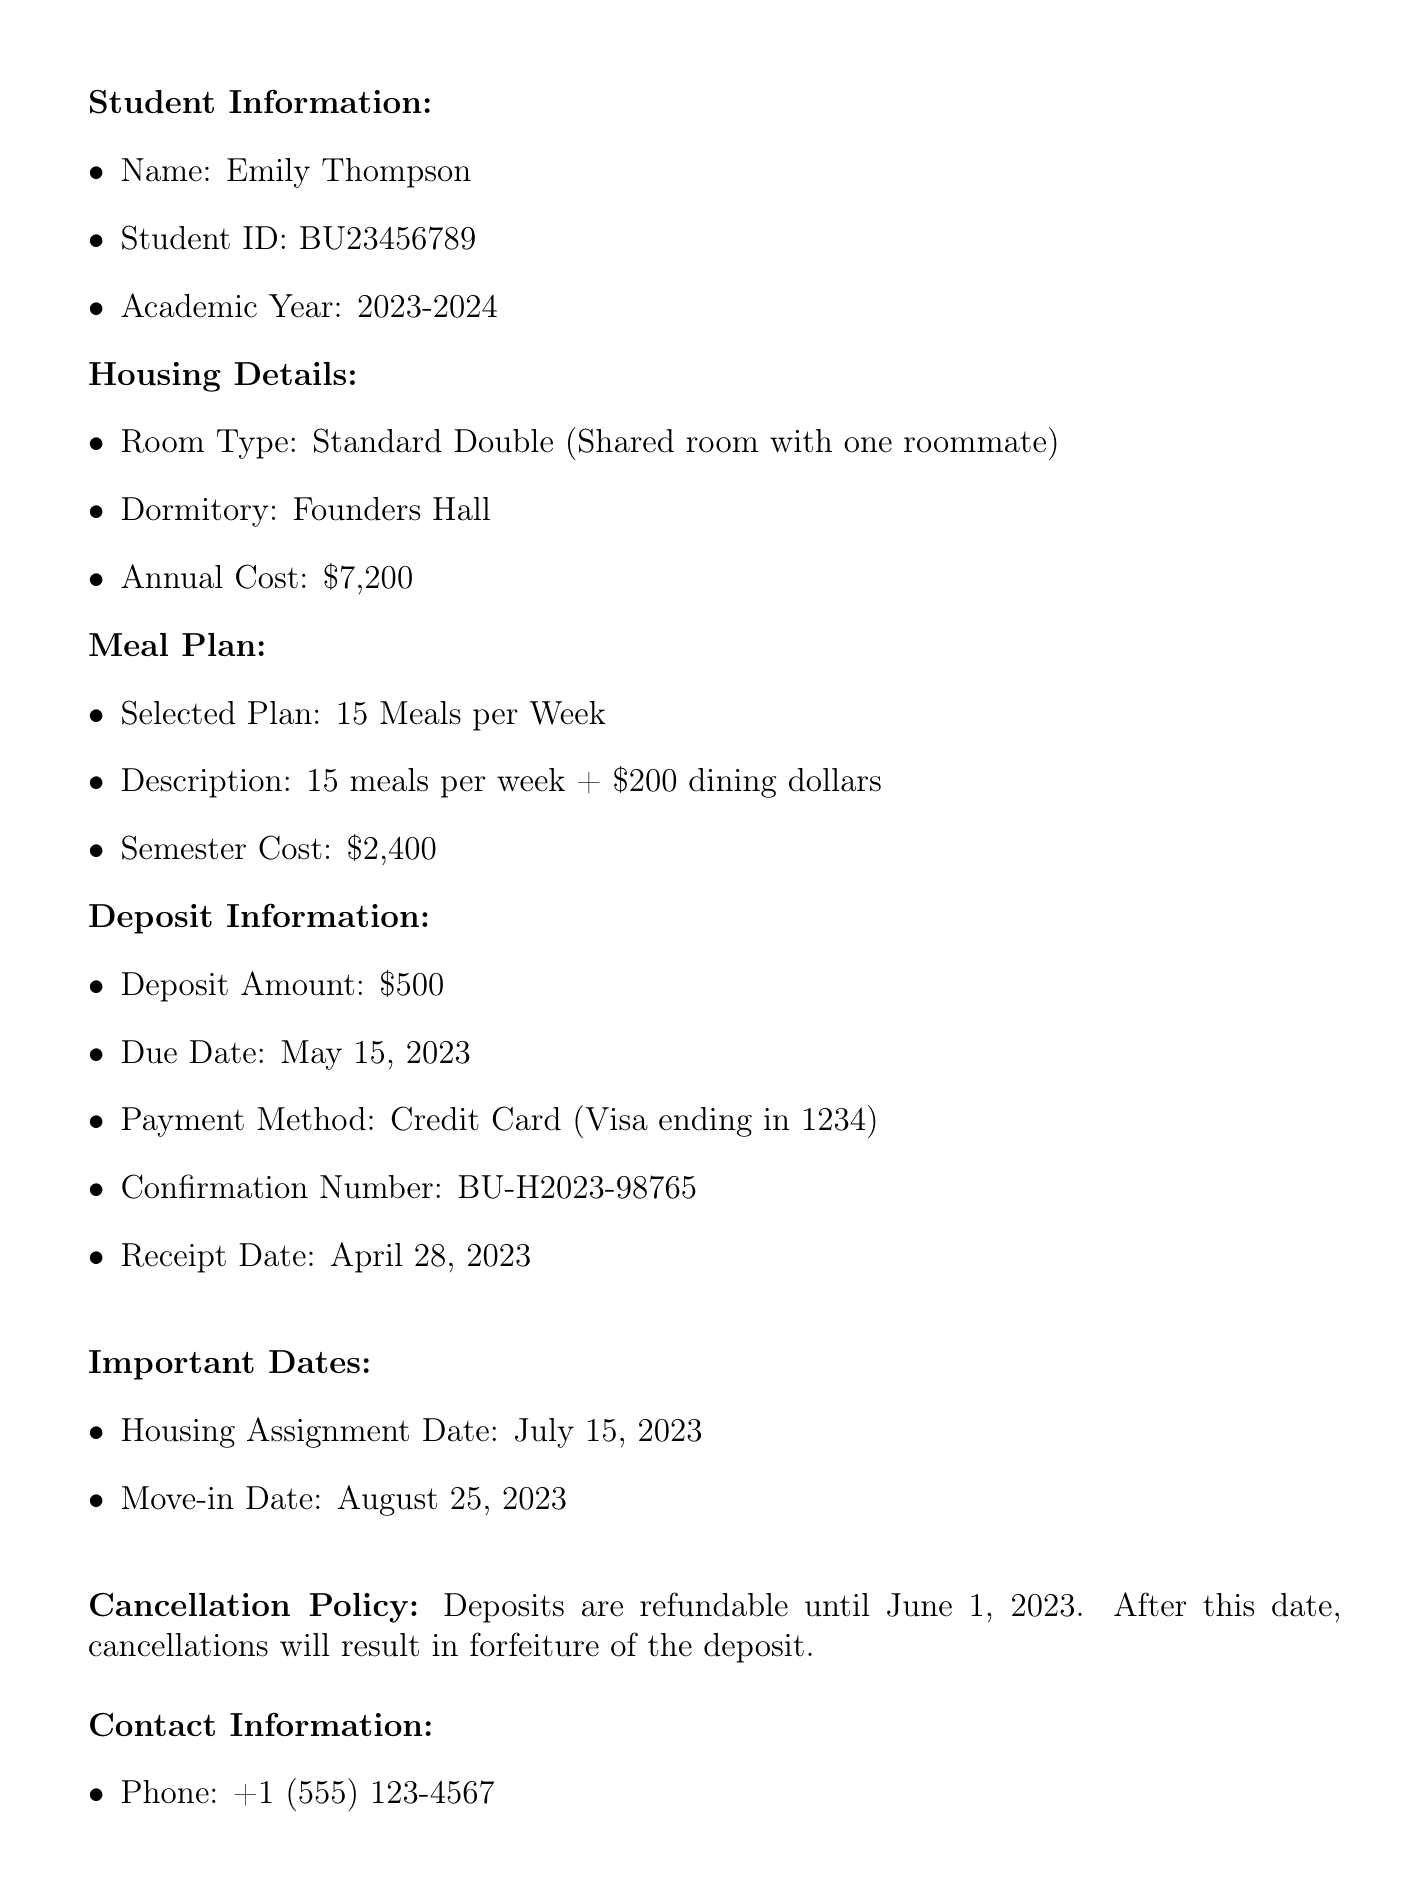What is the name of the student? The document mentions the student's name, which is Emily Thompson.
Answer: Emily Thompson What is the deposit amount? The deposit amount stated in the document is $500.
Answer: $500 When is the deposit due date? The document specifies the deposit due date is May 15, 2023.
Answer: May 15, 2023 What room type did the student select? The selected room type for the student is mentioned as Standard Double.
Answer: Standard Double What is the annual cost of the selected room type? The annual cost of the Standard Double room is provided in the document as $7200.
Answer: $7200 What is the selected meal plan? The document indicates that the selected meal plan is "15 Meals per Week."
Answer: 15 Meals per Week Is the deposit refundable after June 1, 2023? The cancellation policy states that deposits are refundable until June 1, 2023, meaning deposits after this date are not refundable.
Answer: No What date does the student move in? The move-in date for the student is given as August 25, 2023.
Answer: August 25, 2023 What payment method was used? The document specifies that the selected payment method is Credit Card.
Answer: Credit Card 